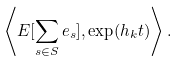<formula> <loc_0><loc_0><loc_500><loc_500>\left \langle E [ \sum _ { s \in S } e _ { s } ] , \exp ( h _ { k } t ) \right \rangle .</formula> 